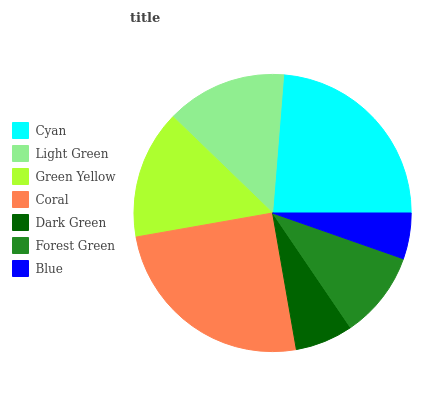Is Blue the minimum?
Answer yes or no. Yes. Is Coral the maximum?
Answer yes or no. Yes. Is Light Green the minimum?
Answer yes or no. No. Is Light Green the maximum?
Answer yes or no. No. Is Cyan greater than Light Green?
Answer yes or no. Yes. Is Light Green less than Cyan?
Answer yes or no. Yes. Is Light Green greater than Cyan?
Answer yes or no. No. Is Cyan less than Light Green?
Answer yes or no. No. Is Light Green the high median?
Answer yes or no. Yes. Is Light Green the low median?
Answer yes or no. Yes. Is Dark Green the high median?
Answer yes or no. No. Is Green Yellow the low median?
Answer yes or no. No. 